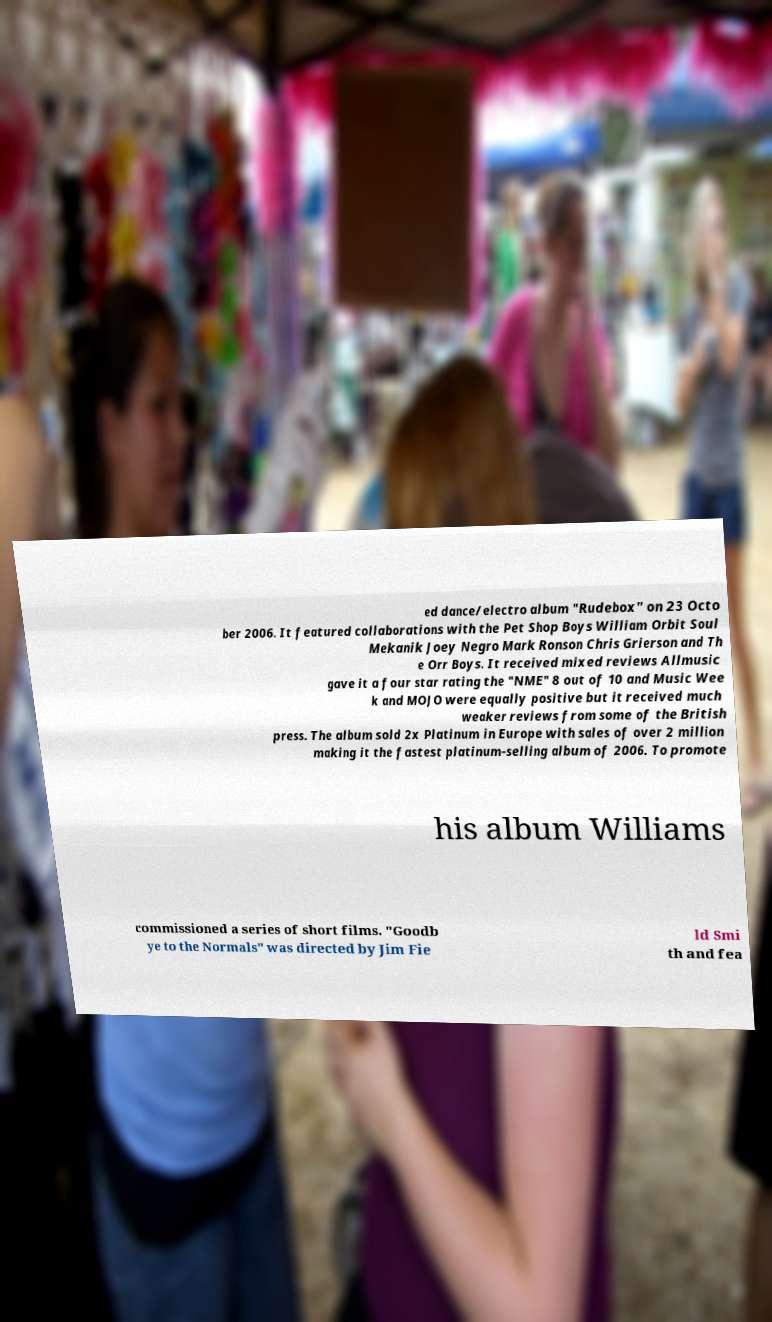Can you accurately transcribe the text from the provided image for me? ed dance/electro album "Rudebox" on 23 Octo ber 2006. It featured collaborations with the Pet Shop Boys William Orbit Soul Mekanik Joey Negro Mark Ronson Chris Grierson and Th e Orr Boys. It received mixed reviews Allmusic gave it a four star rating the "NME" 8 out of 10 and Music Wee k and MOJO were equally positive but it received much weaker reviews from some of the British press. The album sold 2x Platinum in Europe with sales of over 2 million making it the fastest platinum-selling album of 2006. To promote his album Williams commissioned a series of short films. "Goodb ye to the Normals" was directed by Jim Fie ld Smi th and fea 